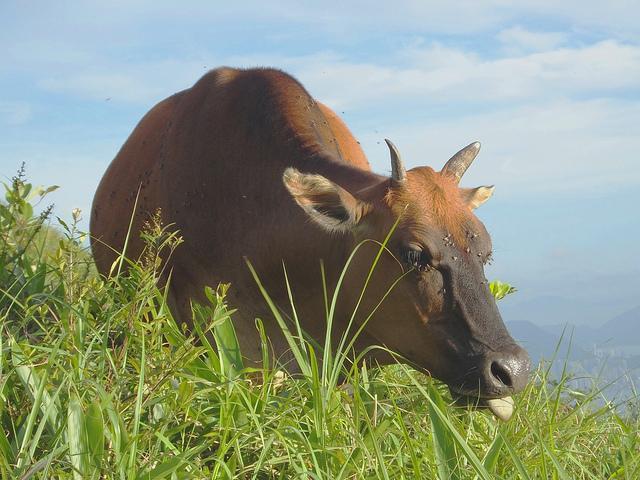How many brown cows are there?
Give a very brief answer. 1. 